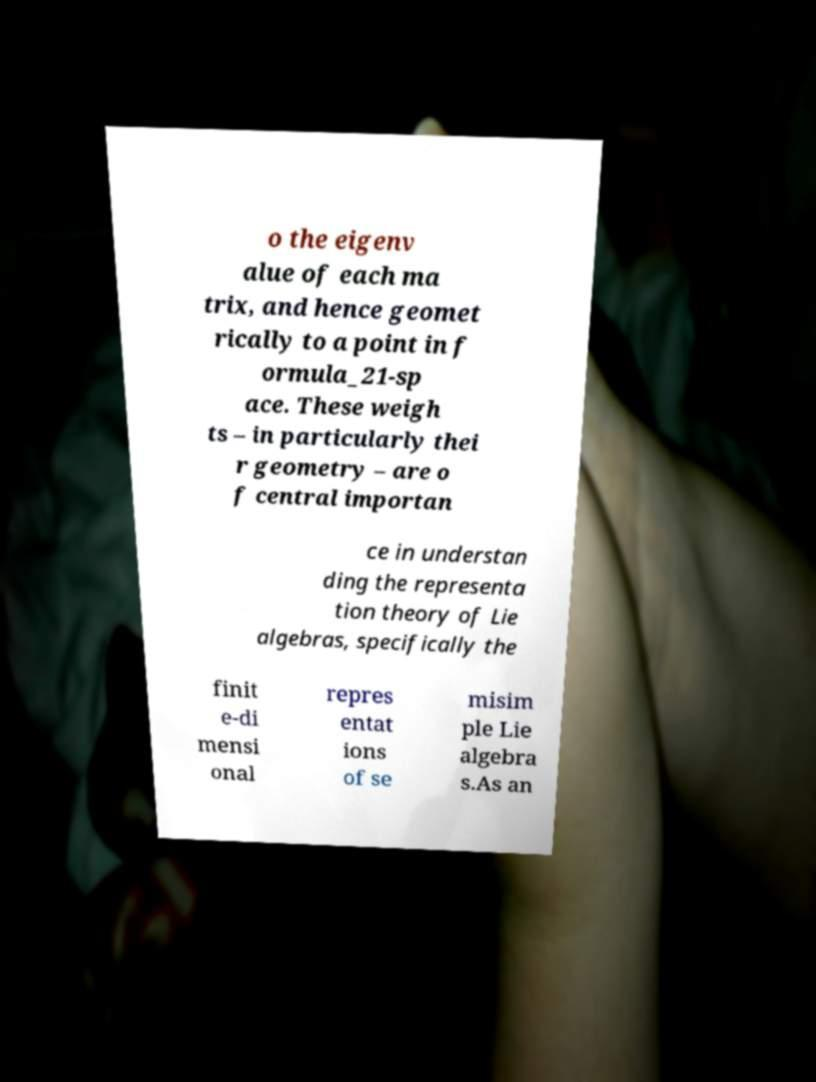For documentation purposes, I need the text within this image transcribed. Could you provide that? o the eigenv alue of each ma trix, and hence geomet rically to a point in f ormula_21-sp ace. These weigh ts – in particularly thei r geometry – are o f central importan ce in understan ding the representa tion theory of Lie algebras, specifically the finit e-di mensi onal repres entat ions of se misim ple Lie algebra s.As an 